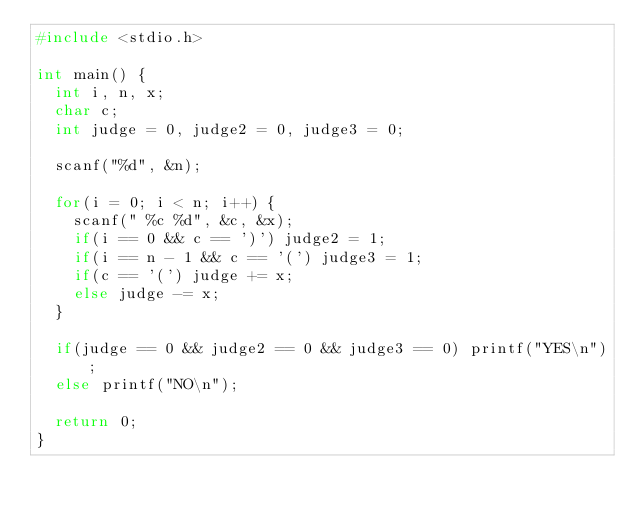Convert code to text. <code><loc_0><loc_0><loc_500><loc_500><_C_>#include <stdio.h>

int main() {
  int i, n, x;
  char c;
  int judge = 0, judge2 = 0, judge3 = 0;

  scanf("%d", &n);

  for(i = 0; i < n; i++) {
    scanf(" %c %d", &c, &x);
    if(i == 0 && c == ')') judge2 = 1;
    if(i == n - 1 && c == '(') judge3 = 1; 
    if(c == '(') judge += x;
    else judge -= x;
  }

  if(judge == 0 && judge2 == 0 && judge3 == 0) printf("YES\n");
  else printf("NO\n");

  return 0;
}</code> 